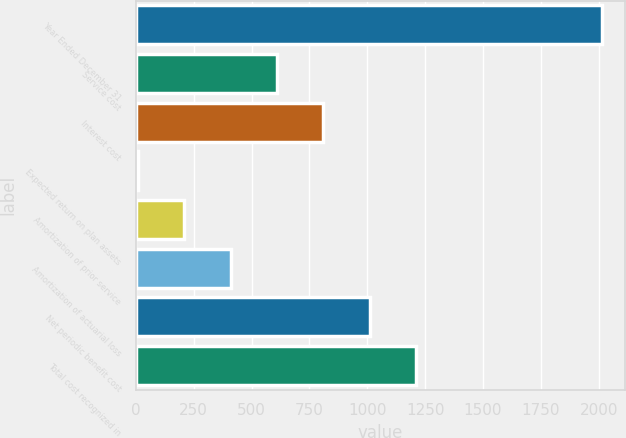<chart> <loc_0><loc_0><loc_500><loc_500><bar_chart><fcel>Year Ended December 31<fcel>Service cost<fcel>Interest cost<fcel>Expected return on plan assets<fcel>Amortization of prior service<fcel>Amortization of actuarial loss<fcel>Net periodic benefit cost<fcel>Total cost recognized in<nl><fcel>2013<fcel>610.2<fcel>810.6<fcel>9<fcel>209.4<fcel>409.8<fcel>1011<fcel>1211.4<nl></chart> 